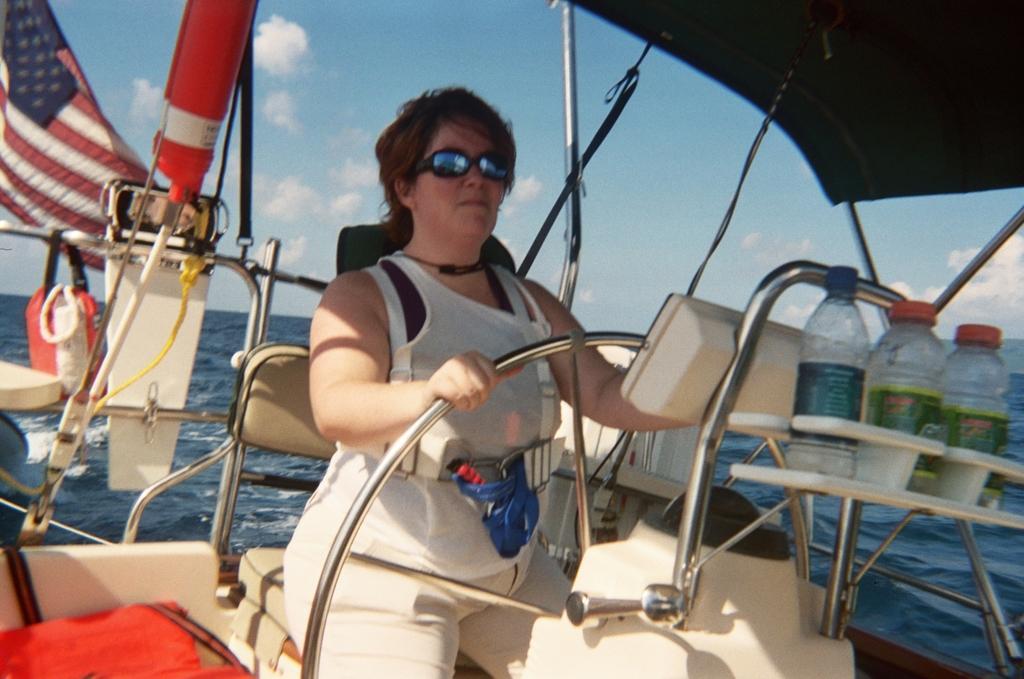Describe this image in one or two sentences. This picture might be taken on ocean and it is sunny. In this image, in the middle, we can see a woman sitting on the boat and driving a boat. On the right side, we can see three bottles which are placed on the stand. On the left side, we can also see some flags. On the top there is a cloth. In the background, we can see a water in a ocean. 